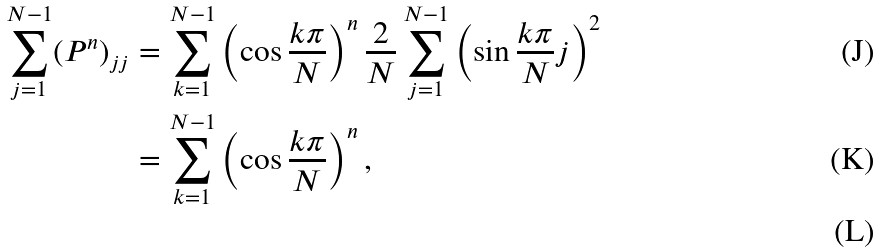Convert formula to latex. <formula><loc_0><loc_0><loc_500><loc_500>\sum _ { j = 1 } ^ { N - 1 } ( P ^ { n } ) _ { j j } & = \sum _ { k = 1 } ^ { N - 1 } \left ( \cos \frac { k \pi } { N } \right ) ^ { n } \frac { 2 } { N } \sum _ { j = 1 } ^ { N - 1 } \left ( \sin \frac { k \pi } { N } j \right ) ^ { 2 } \\ & = \sum _ { k = 1 } ^ { N - 1 } \left ( \cos \frac { k \pi } { N } \right ) ^ { n } , \\</formula> 